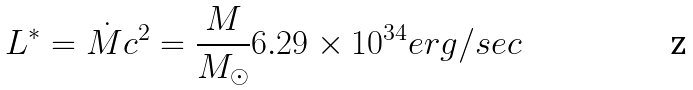<formula> <loc_0><loc_0><loc_500><loc_500>L ^ { * } = \dot { M } c ^ { 2 } = \frac { M } { M _ { \odot } } 6 . 2 9 \times 1 0 ^ { 3 4 } e r g / { s e c }</formula> 